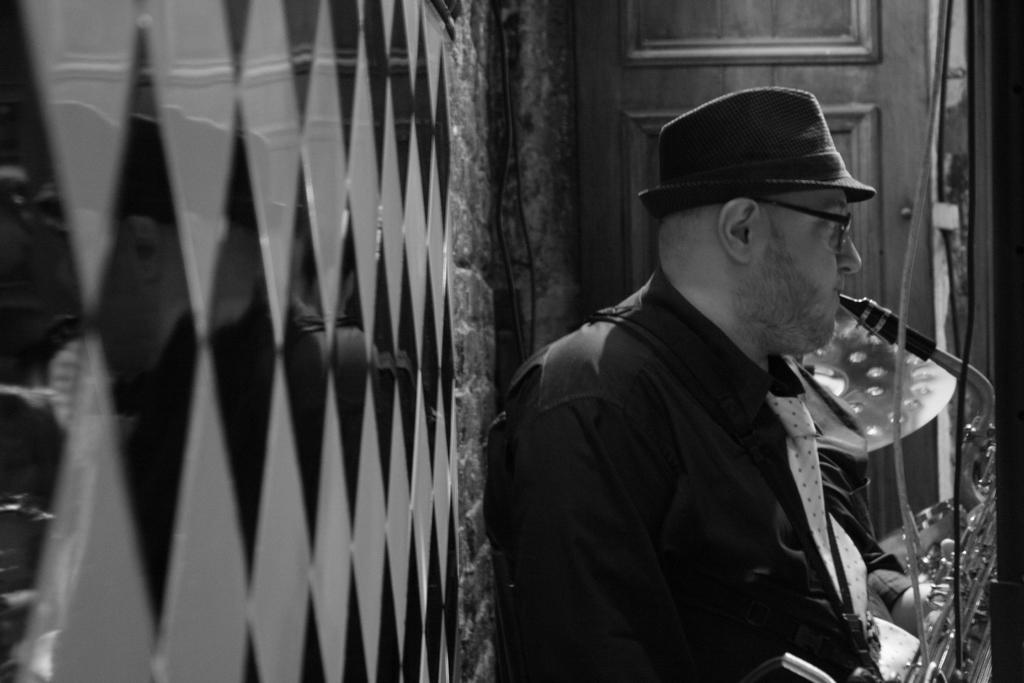What is the man on the right side of the image holding? The man is holding a trumpet. What is the man wearing on his head? The man is wearing a hat. What can be seen on the left side of the image? There is a wall on the left side of the image. What architectural feature is at the top of the image? There is a door at the top of the image. What type of club can be seen in the man's hand in the image? There is no club present in the image; the man is holding a trumpet. What type of soda is the man drinking in the image? There is no soda present in the image; the man is holding a trumpet and wearing a hat. 